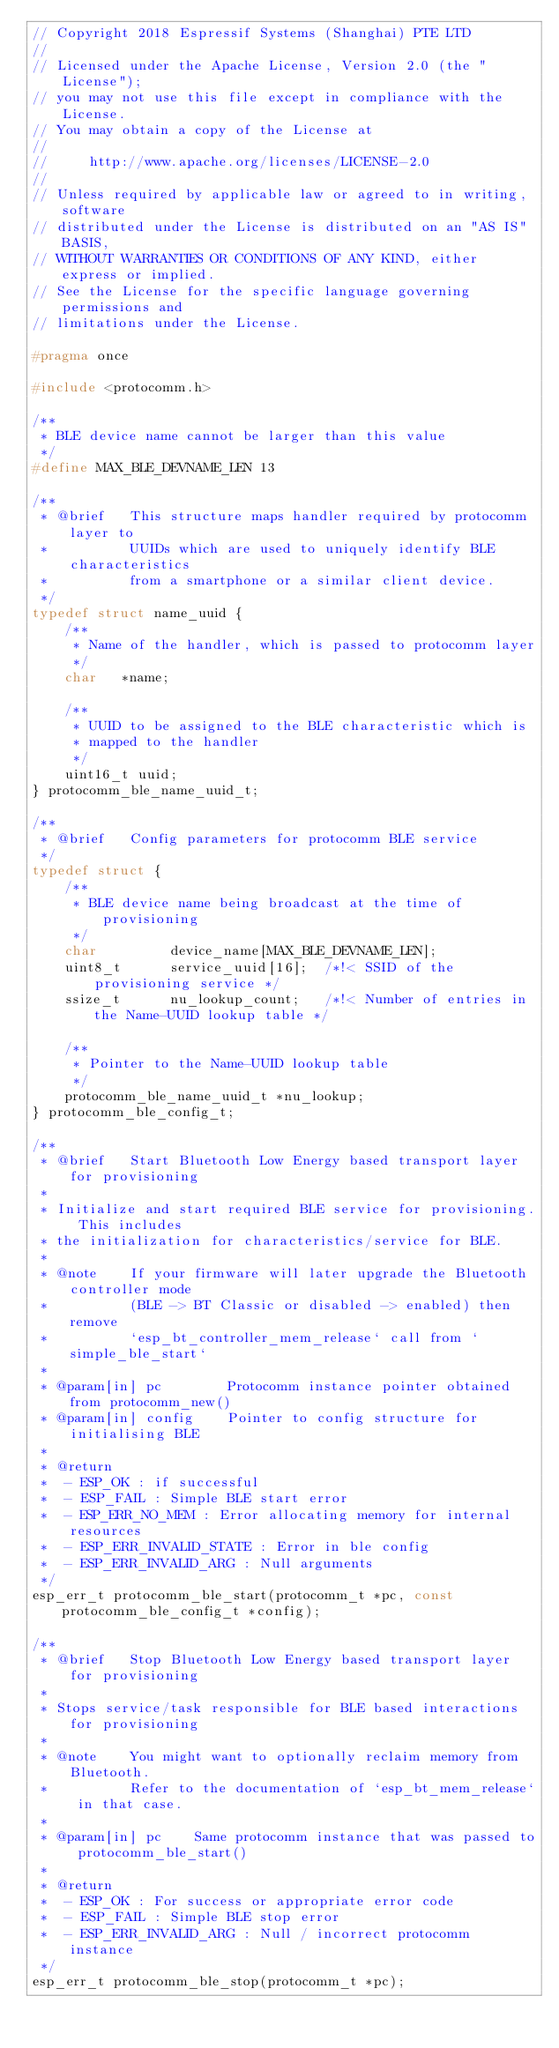Convert code to text. <code><loc_0><loc_0><loc_500><loc_500><_C_>// Copyright 2018 Espressif Systems (Shanghai) PTE LTD
//
// Licensed under the Apache License, Version 2.0 (the "License");
// you may not use this file except in compliance with the License.
// You may obtain a copy of the License at
//
//     http://www.apache.org/licenses/LICENSE-2.0
//
// Unless required by applicable law or agreed to in writing, software
// distributed under the License is distributed on an "AS IS" BASIS,
// WITHOUT WARRANTIES OR CONDITIONS OF ANY KIND, either express or implied.
// See the License for the specific language governing permissions and
// limitations under the License.

#pragma once

#include <protocomm.h>

/**
 * BLE device name cannot be larger than this value
 */
#define MAX_BLE_DEVNAME_LEN 13

/**
 * @brief   This structure maps handler required by protocomm layer to
 *          UUIDs which are used to uniquely identify BLE characteristics
 *          from a smartphone or a similar client device.
 */
typedef struct name_uuid {
    /**
     * Name of the handler, which is passed to protocomm layer
     */
    char   *name;

    /**
     * UUID to be assigned to the BLE characteristic which is
     * mapped to the handler
     */
    uint16_t uuid;
} protocomm_ble_name_uuid_t;

/**
 * @brief   Config parameters for protocomm BLE service
 */
typedef struct {
    /**
     * BLE device name being broadcast at the time of provisioning
     */
    char         device_name[MAX_BLE_DEVNAME_LEN];
    uint8_t      service_uuid[16];  /*!< SSID of the provisioning service */
    ssize_t      nu_lookup_count;   /*!< Number of entries in the Name-UUID lookup table */

    /**
     * Pointer to the Name-UUID lookup table
     */
    protocomm_ble_name_uuid_t *nu_lookup;
} protocomm_ble_config_t;

/**
 * @brief   Start Bluetooth Low Energy based transport layer for provisioning
 *
 * Initialize and start required BLE service for provisioning. This includes
 * the initialization for characteristics/service for BLE.
 *
 * @note    If your firmware will later upgrade the Bluetooth controller mode
 *          (BLE -> BT Classic or disabled -> enabled) then remove
 *          `esp_bt_controller_mem_release` call from `simple_ble_start`
 *
 * @param[in] pc        Protocomm instance pointer obtained from protocomm_new()
 * @param[in] config    Pointer to config structure for initialising BLE
 *
 * @return
 *  - ESP_OK : if successful
 *  - ESP_FAIL : Simple BLE start error
 *  - ESP_ERR_NO_MEM : Error allocating memory for internal resources
 *  - ESP_ERR_INVALID_STATE : Error in ble config
 *  - ESP_ERR_INVALID_ARG : Null arguments
 */
esp_err_t protocomm_ble_start(protocomm_t *pc, const protocomm_ble_config_t *config);

/**
 * @brief   Stop Bluetooth Low Energy based transport layer for provisioning
 *
 * Stops service/task responsible for BLE based interactions for provisioning
 *
 * @note    You might want to optionally reclaim memory from Bluetooth.
 *          Refer to the documentation of `esp_bt_mem_release` in that case.
 *
 * @param[in] pc    Same protocomm instance that was passed to protocomm_ble_start()
 *
 * @return
 *  - ESP_OK : For success or appropriate error code
 *  - ESP_FAIL : Simple BLE stop error
 *  - ESP_ERR_INVALID_ARG : Null / incorrect protocomm instance
 */
esp_err_t protocomm_ble_stop(protocomm_t *pc);
</code> 